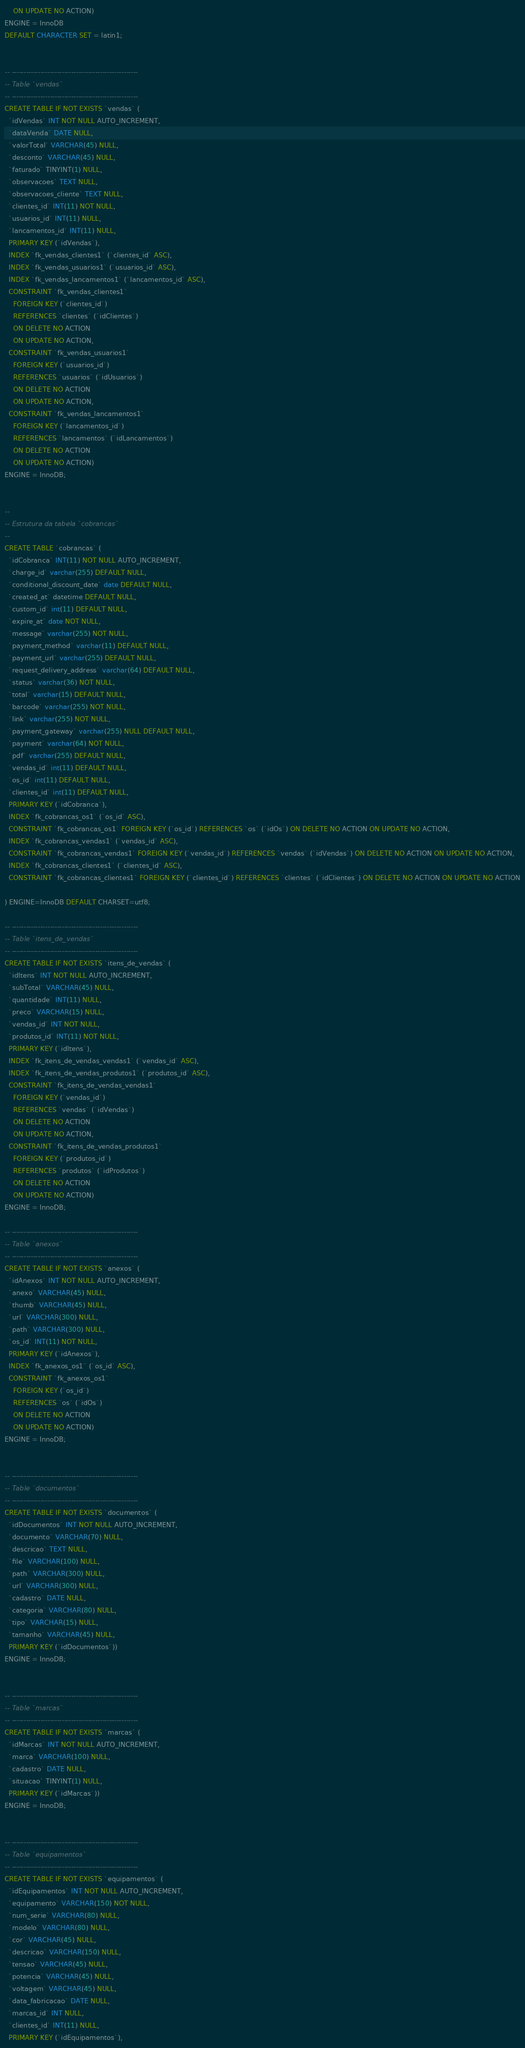Convert code to text. <code><loc_0><loc_0><loc_500><loc_500><_SQL_>    ON UPDATE NO ACTION)
ENGINE = InnoDB
DEFAULT CHARACTER SET = latin1;


-- -----------------------------------------------------
-- Table `vendas`
-- -----------------------------------------------------
CREATE TABLE IF NOT EXISTS `vendas` (
  `idVendas` INT NOT NULL AUTO_INCREMENT,
  `dataVenda` DATE NULL,
  `valorTotal` VARCHAR(45) NULL,
  `desconto` VARCHAR(45) NULL,
  `faturado` TINYINT(1) NULL,
  `observacoes` TEXT NULL,
  `observacoes_cliente` TEXT NULL,
  `clientes_id` INT(11) NOT NULL,
  `usuarios_id` INT(11) NULL,
  `lancamentos_id` INT(11) NULL,
  PRIMARY KEY (`idVendas`),
  INDEX `fk_vendas_clientes1` (`clientes_id` ASC),
  INDEX `fk_vendas_usuarios1` (`usuarios_id` ASC),
  INDEX `fk_vendas_lancamentos1` (`lancamentos_id` ASC),
  CONSTRAINT `fk_vendas_clientes1`
    FOREIGN KEY (`clientes_id`)
    REFERENCES `clientes` (`idClientes`)
    ON DELETE NO ACTION
    ON UPDATE NO ACTION,
  CONSTRAINT `fk_vendas_usuarios1`
    FOREIGN KEY (`usuarios_id`)
    REFERENCES `usuarios` (`idUsuarios`)
    ON DELETE NO ACTION
    ON UPDATE NO ACTION,
  CONSTRAINT `fk_vendas_lancamentos1`
    FOREIGN KEY (`lancamentos_id`)
    REFERENCES `lancamentos` (`idLancamentos`)
    ON DELETE NO ACTION
    ON UPDATE NO ACTION)
ENGINE = InnoDB;


--
-- Estrutura da tabela `cobrancas`
--
CREATE TABLE `cobrancas` (
  `idCobranca` INT(11) NOT NULL AUTO_INCREMENT,
  `charge_id` varchar(255) DEFAULT NULL,
  `conditional_discount_date` date DEFAULT NULL,
  `created_at` datetime DEFAULT NULL,
  `custom_id` int(11) DEFAULT NULL,
  `expire_at` date NOT NULL,
  `message` varchar(255) NOT NULL,
  `payment_method` varchar(11) DEFAULT NULL,
  `payment_url` varchar(255) DEFAULT NULL,
  `request_delivery_address` varchar(64) DEFAULT NULL,
  `status` varchar(36) NOT NULL,
  `total` varchar(15) DEFAULT NULL,
  `barcode` varchar(255) NOT NULL,
  `link` varchar(255) NOT NULL,
  `payment_gateway` varchar(255) NULL DEFAULT NULL,
  `payment` varchar(64) NOT NULL,
  `pdf` varchar(255) DEFAULT NULL,
  `vendas_id` int(11) DEFAULT NULL,
  `os_id` int(11) DEFAULT NULL,
  `clientes_id` int(11) DEFAULT NULL,
  PRIMARY KEY (`idCobranca`),
  INDEX `fk_cobrancas_os1` (`os_id` ASC),
  CONSTRAINT `fk_cobrancas_os1` FOREIGN KEY (`os_id`) REFERENCES `os` (`idOs`) ON DELETE NO ACTION ON UPDATE NO ACTION,
  INDEX `fk_cobrancas_vendas1` (`vendas_id` ASC),
  CONSTRAINT `fk_cobrancas_vendas1` FOREIGN KEY (`vendas_id`) REFERENCES `vendas` (`idVendas`) ON DELETE NO ACTION ON UPDATE NO ACTION,
  INDEX `fk_cobrancas_clientes1` (`clientes_id` ASC),
  CONSTRAINT `fk_cobrancas_clientes1` FOREIGN KEY (`clientes_id`) REFERENCES `clientes` (`idClientes`) ON DELETE NO ACTION ON UPDATE NO ACTION

) ENGINE=InnoDB DEFAULT CHARSET=utf8;

-- -----------------------------------------------------
-- Table `itens_de_vendas`
-- -----------------------------------------------------
CREATE TABLE IF NOT EXISTS `itens_de_vendas` (
  `idItens` INT NOT NULL AUTO_INCREMENT,
  `subTotal` VARCHAR(45) NULL,
  `quantidade` INT(11) NULL,
  `preco` VARCHAR(15) NULL,
  `vendas_id` INT NOT NULL,
  `produtos_id` INT(11) NOT NULL,
  PRIMARY KEY (`idItens`),
  INDEX `fk_itens_de_vendas_vendas1` (`vendas_id` ASC),
  INDEX `fk_itens_de_vendas_produtos1` (`produtos_id` ASC),
  CONSTRAINT `fk_itens_de_vendas_vendas1`
    FOREIGN KEY (`vendas_id`)
    REFERENCES `vendas` (`idVendas`)
    ON DELETE NO ACTION
    ON UPDATE NO ACTION,
  CONSTRAINT `fk_itens_de_vendas_produtos1`
    FOREIGN KEY (`produtos_id`)
    REFERENCES `produtos` (`idProdutos`)
    ON DELETE NO ACTION
    ON UPDATE NO ACTION)
ENGINE = InnoDB;

-- -----------------------------------------------------
-- Table `anexos`
-- -----------------------------------------------------
CREATE TABLE IF NOT EXISTS `anexos` (
  `idAnexos` INT NOT NULL AUTO_INCREMENT,
  `anexo` VARCHAR(45) NULL,
  `thumb` VARCHAR(45) NULL,
  `url` VARCHAR(300) NULL,
  `path` VARCHAR(300) NULL,
  `os_id` INT(11) NOT NULL,
  PRIMARY KEY (`idAnexos`),
  INDEX `fk_anexos_os1` (`os_id` ASC),
  CONSTRAINT `fk_anexos_os1`
    FOREIGN KEY (`os_id`)
    REFERENCES `os` (`idOs`)
    ON DELETE NO ACTION
    ON UPDATE NO ACTION)
ENGINE = InnoDB;


-- -----------------------------------------------------
-- Table `documentos`
-- -----------------------------------------------------
CREATE TABLE IF NOT EXISTS `documentos` (
  `idDocumentos` INT NOT NULL AUTO_INCREMENT,
  `documento` VARCHAR(70) NULL,
  `descricao` TEXT NULL,
  `file` VARCHAR(100) NULL,
  `path` VARCHAR(300) NULL,
  `url` VARCHAR(300) NULL,
  `cadastro` DATE NULL,
  `categoria` VARCHAR(80) NULL,
  `tipo` VARCHAR(15) NULL,
  `tamanho` VARCHAR(45) NULL,
  PRIMARY KEY (`idDocumentos`))
ENGINE = InnoDB;


-- -----------------------------------------------------
-- Table `marcas`
-- -----------------------------------------------------
CREATE TABLE IF NOT EXISTS `marcas` (
  `idMarcas` INT NOT NULL AUTO_INCREMENT,
  `marca` VARCHAR(100) NULL,
  `cadastro` DATE NULL,
  `situacao` TINYINT(1) NULL,
  PRIMARY KEY (`idMarcas`))
ENGINE = InnoDB;


-- -----------------------------------------------------
-- Table `equipamentos`
-- -----------------------------------------------------
CREATE TABLE IF NOT EXISTS `equipamentos` (
  `idEquipamentos` INT NOT NULL AUTO_INCREMENT,
  `equipamento` VARCHAR(150) NOT NULL,
  `num_serie` VARCHAR(80) NULL,
  `modelo` VARCHAR(80) NULL,
  `cor` VARCHAR(45) NULL,
  `descricao` VARCHAR(150) NULL,
  `tensao` VARCHAR(45) NULL,
  `potencia` VARCHAR(45) NULL,
  `voltagem` VARCHAR(45) NULL,
  `data_fabricacao` DATE NULL,
  `marcas_id` INT NULL,
  `clientes_id` INT(11) NULL,
  PRIMARY KEY (`idEquipamentos`),</code> 